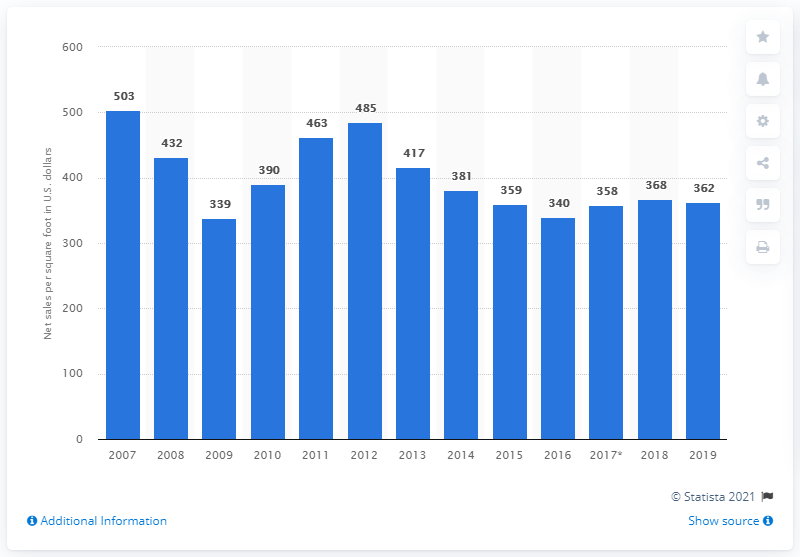Indicate a few pertinent items in this graphic. In 2019, the net store sales per average gross square foot of Abercrombie & Fitch Company were 362. 